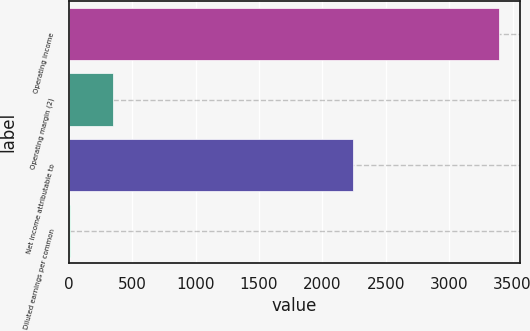Convert chart. <chart><loc_0><loc_0><loc_500><loc_500><bar_chart><fcel>Operating income<fcel>Operating margin (2)<fcel>Net income attributable to<fcel>Diluted earnings per common<nl><fcel>3392<fcel>349.87<fcel>2239<fcel>11.85<nl></chart> 